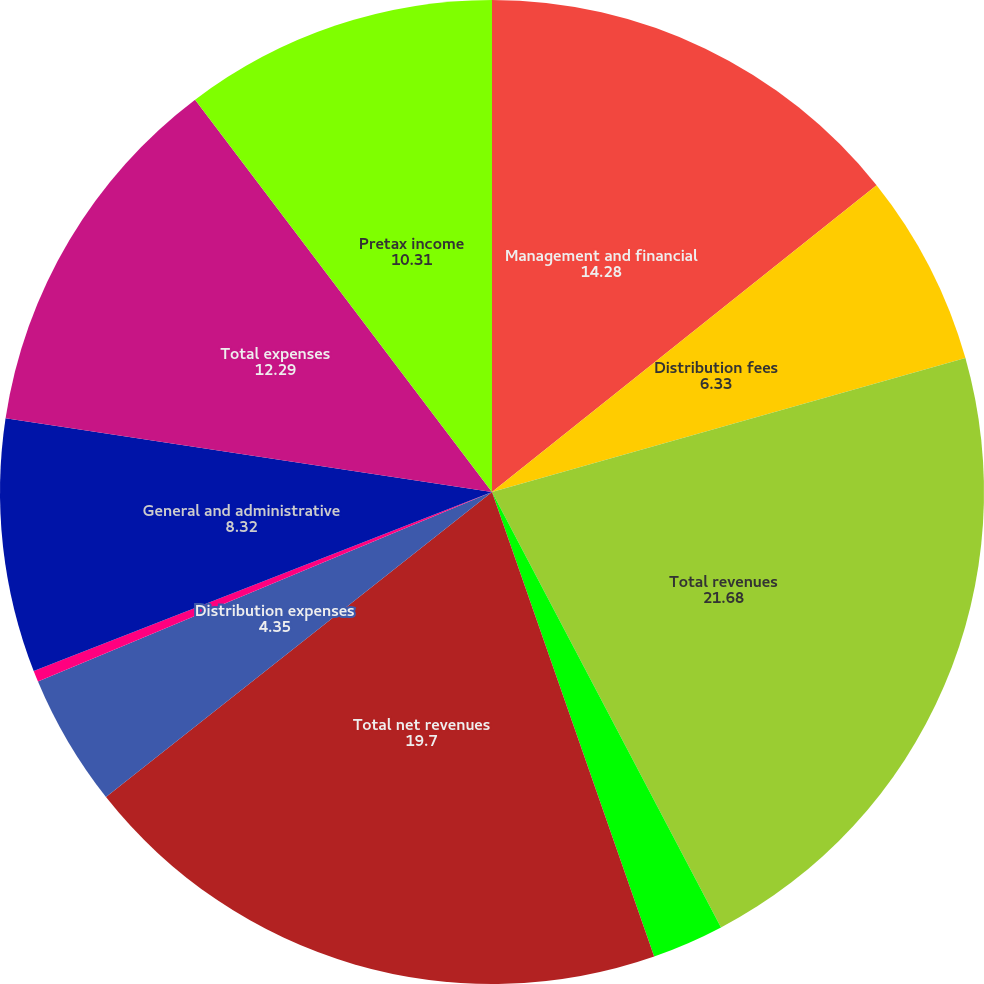Convert chart to OTSL. <chart><loc_0><loc_0><loc_500><loc_500><pie_chart><fcel>Management and financial<fcel>Distribution fees<fcel>Total revenues<fcel>Banking and deposit interest<fcel>Total net revenues<fcel>Distribution expenses<fcel>Amortization of deferred<fcel>General and administrative<fcel>Total expenses<fcel>Pretax income<nl><fcel>14.28%<fcel>6.33%<fcel>21.68%<fcel>2.36%<fcel>19.7%<fcel>4.35%<fcel>0.37%<fcel>8.32%<fcel>12.29%<fcel>10.31%<nl></chart> 